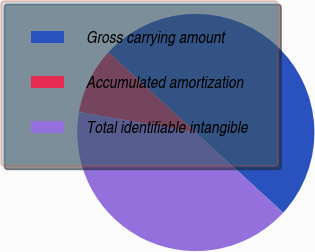Convert chart. <chart><loc_0><loc_0><loc_500><loc_500><pie_chart><fcel>Gross carrying amount<fcel>Accumulated amortization<fcel>Total identifiable intangible<nl><fcel>50.0%<fcel>9.06%<fcel>40.94%<nl></chart> 